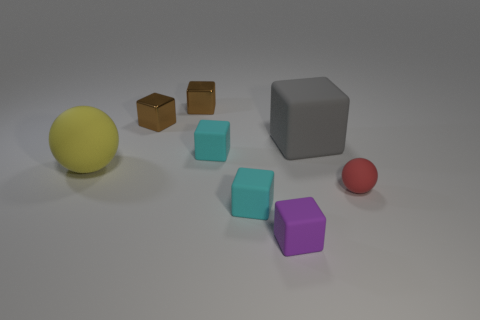What color is the rubber ball that is the same size as the purple rubber cube?
Make the answer very short. Red. Is the number of small blocks to the left of the tiny rubber sphere greater than the number of cyan objects?
Keep it short and to the point. Yes. What material is the tiny object that is behind the small red ball and in front of the large gray object?
Ensure brevity in your answer.  Rubber. Is there anything else that has the same shape as the purple rubber thing?
Provide a short and direct response. Yes. What number of rubber objects are both to the left of the purple matte thing and in front of the tiny rubber sphere?
Your answer should be compact. 1. What is the red sphere made of?
Give a very brief answer. Rubber. Are there an equal number of tiny metallic things that are right of the red sphere and large matte spheres?
Ensure brevity in your answer.  No. How many other things have the same shape as the large yellow object?
Ensure brevity in your answer.  1. Is the shape of the purple matte object the same as the tiny red matte object?
Provide a succinct answer. No. What number of objects are either tiny rubber blocks that are to the left of the purple thing or blocks?
Your answer should be compact. 6. 